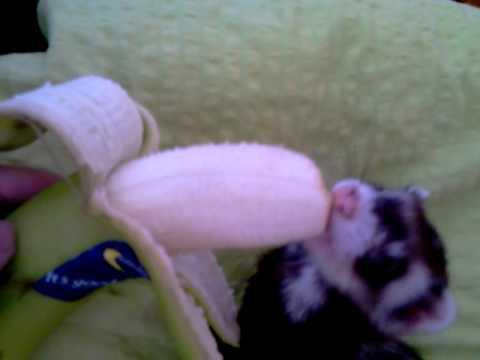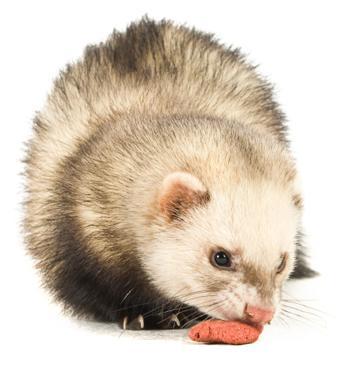The first image is the image on the left, the second image is the image on the right. For the images shown, is this caption "There are two ferrets eating something." true? Answer yes or no. Yes. The first image is the image on the left, the second image is the image on the right. Examine the images to the left and right. Is the description "There is a partially peeled banana being eaten by a ferret in the left image." accurate? Answer yes or no. Yes. 